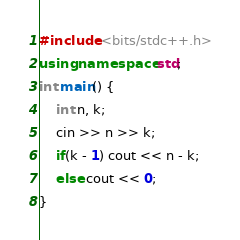<code> <loc_0><loc_0><loc_500><loc_500><_C++_>#include <bits/stdc++.h>
using namespace std;
int main() {
    int n, k;
    cin >> n >> k;
    if(k - 1) cout << n - k;
    else cout << 0;
}
</code> 